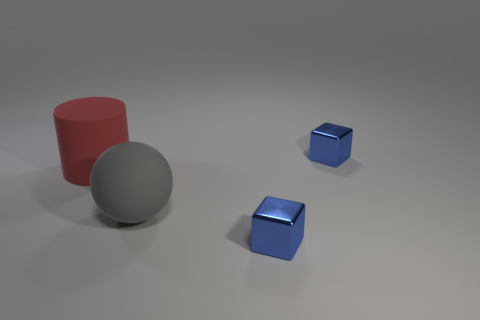Add 3 tiny blue cylinders. How many objects exist? 7 Subtract all spheres. How many objects are left? 3 Add 2 small shiny things. How many small shiny things are left? 4 Add 2 gray spheres. How many gray spheres exist? 3 Subtract 0 gray cylinders. How many objects are left? 4 Subtract all green shiny cubes. Subtract all tiny blocks. How many objects are left? 2 